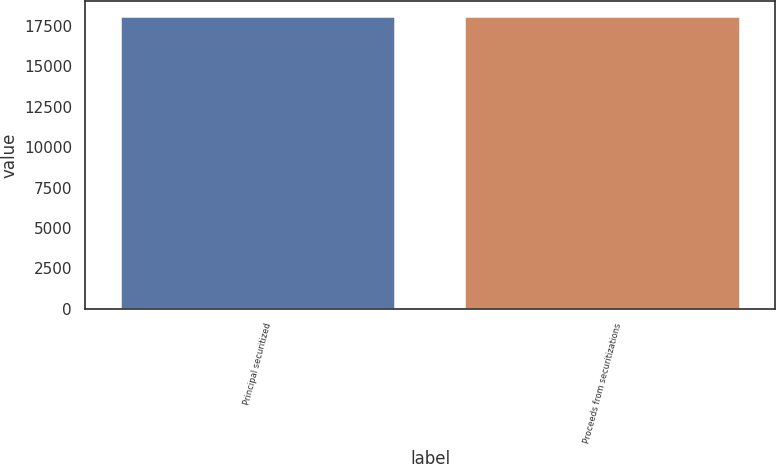Convert chart to OTSL. <chart><loc_0><loc_0><loc_500><loc_500><bar_chart><fcel>Principal securitized<fcel>Proceeds from securitizations<nl><fcel>18125<fcel>18093<nl></chart> 